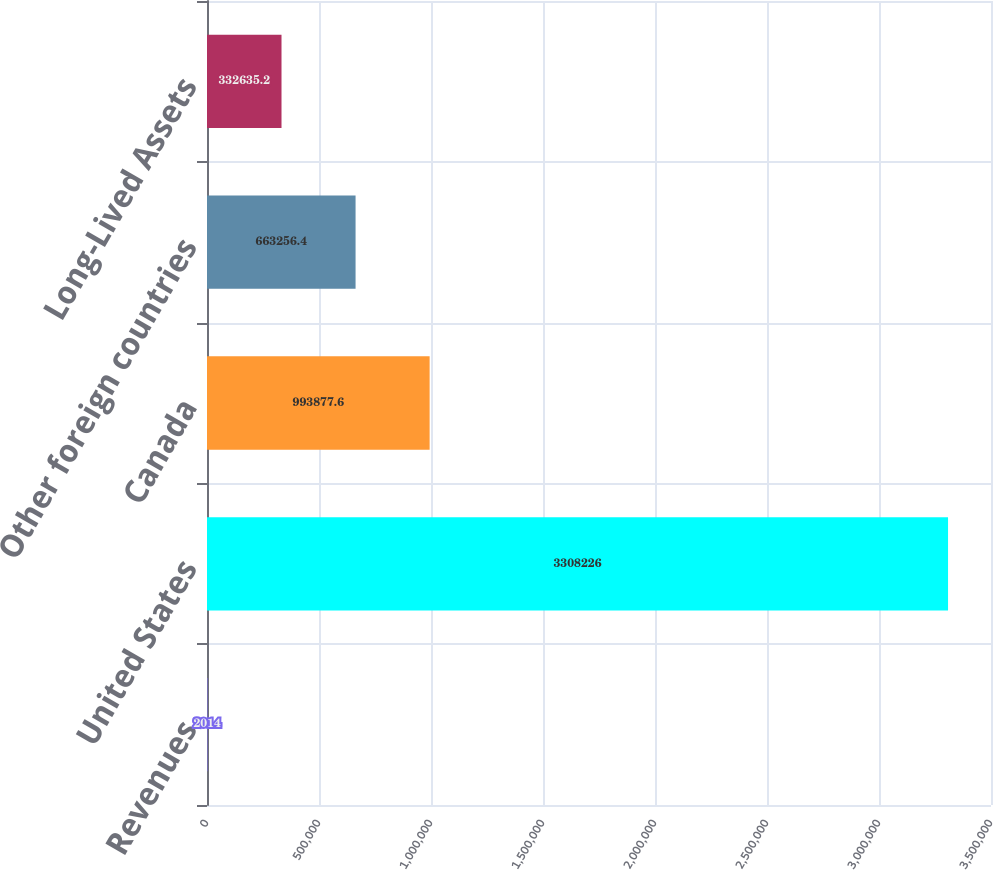<chart> <loc_0><loc_0><loc_500><loc_500><bar_chart><fcel>Revenues<fcel>United States<fcel>Canada<fcel>Other foreign countries<fcel>Long-Lived Assets<nl><fcel>2014<fcel>3.30823e+06<fcel>993878<fcel>663256<fcel>332635<nl></chart> 